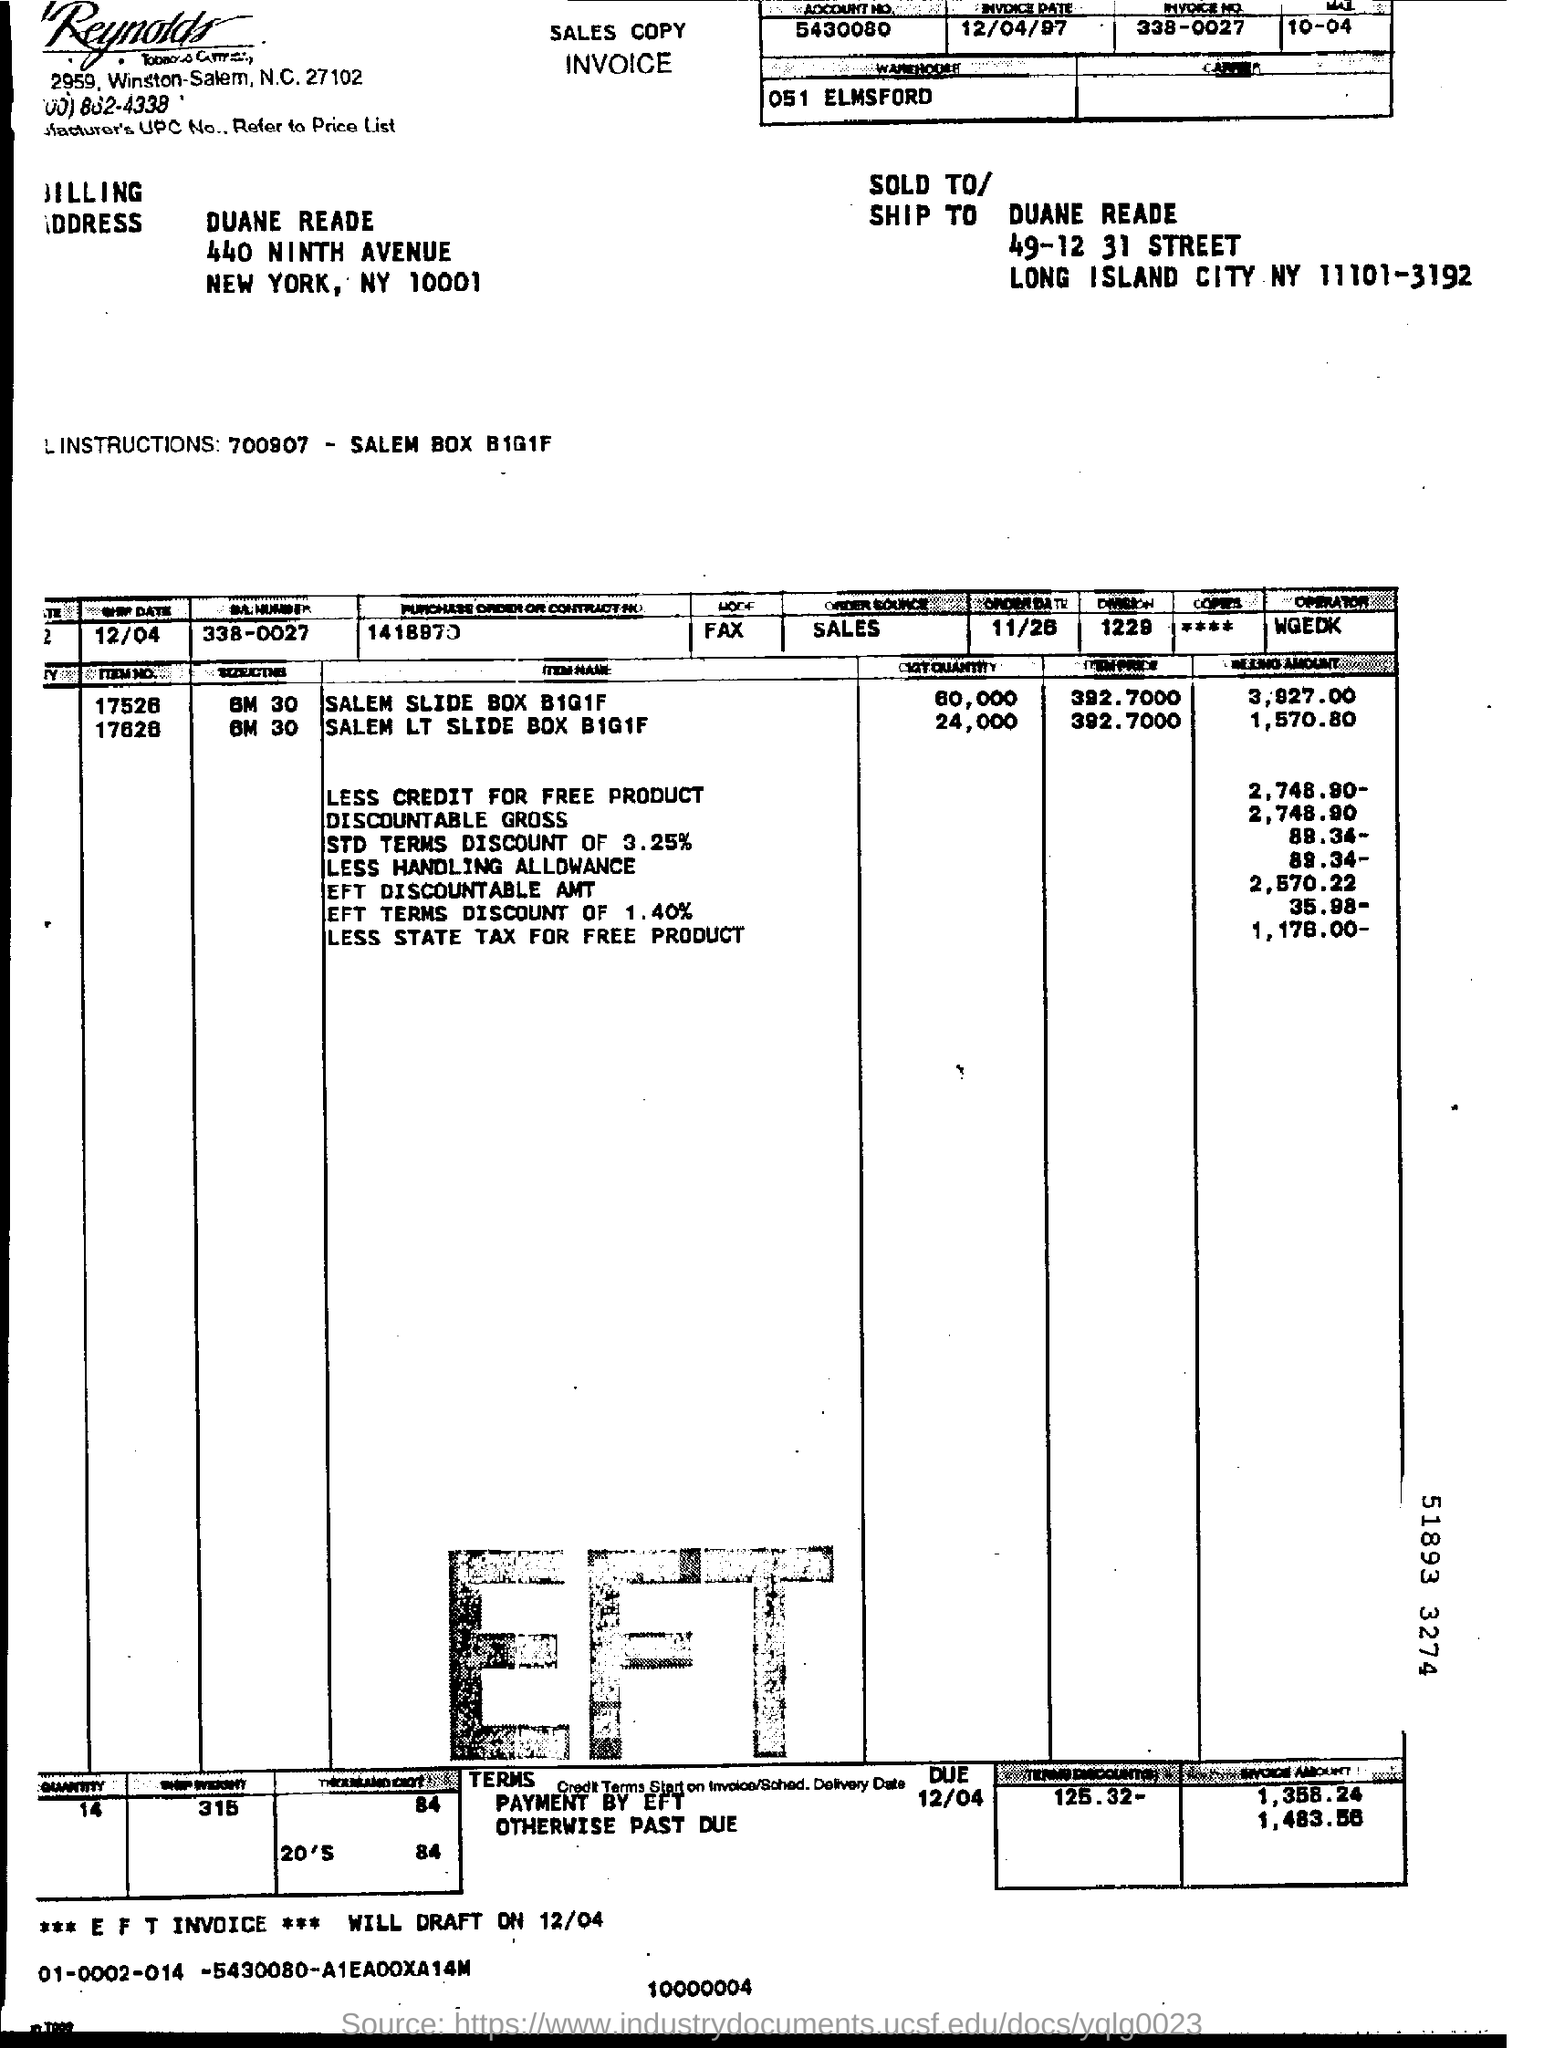What is the account number?
Offer a terse response. 5430080. When is the invoice dated?
Offer a terse response. 12/04/97. What is the invoice number?
Offer a terse response. 338-0027. 